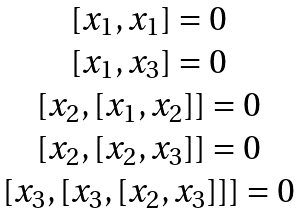Convert formula to latex. <formula><loc_0><loc_0><loc_500><loc_500>\begin{matrix} { { [ x _ { 1 } , x _ { 1 } ] } = 0 } \\ { { [ x _ { 1 } , x _ { 3 } ] } = 0 } \\ { { [ x _ { 2 } , [ x _ { 1 } , x _ { 2 } ] ] } = 0 } \\ { { [ x _ { 2 } , [ x _ { 2 } , x _ { 3 } ] ] } = 0 } \\ { { [ x _ { 3 } , [ x _ { 3 } , [ x _ { 2 } , x _ { 3 } ] ] ] } = 0 } \end{matrix}</formula> 